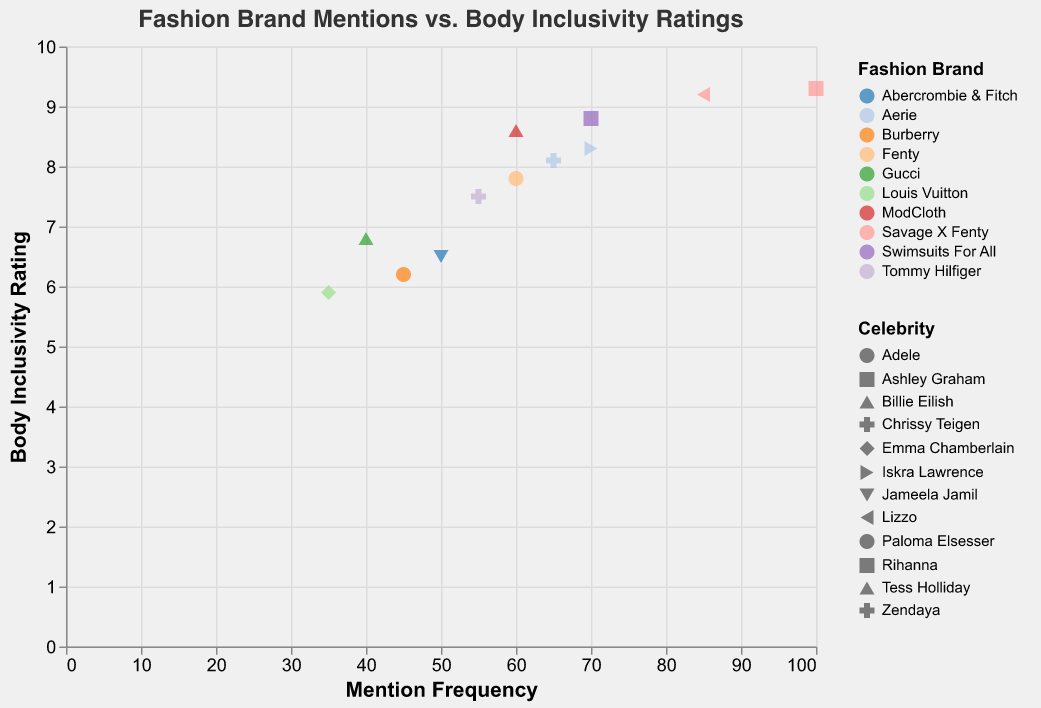What is the title of the plot? The title of the plot is located at the top and it provides a brief summary of what the plot represents.
Answer: Fashion Brand Mentions vs. Body Inclusivity Ratings Which celebrity endorses Savage X Fenty, and what is their body inclusivity rating? Locate the color corresponding to "Savage X Fenty" in the legend and find the data points. Check the celebrity and the body inclusivity rating in the tooltip.
Answer: Lizzo, 9.2, and Rihanna, 9.3 Which fashion brand has the highest mention frequency and what is it? Check the x-axis for the data point with the highest value and cross-reference with the tooltip or legend.
Answer: Savage X Fenty, 100 Compare the mention frequency and body inclusivity rating between Ashley Graham and Billie Eilish. Look for their data points using their shapes in the legend. For Ashley Graham, the mention frequency is 70 and the rating is 8.8. For Billie Eilish, the mention frequency is 40 and the rating is 6.8.
Answer: Ashley Graham: 70 mentions, 8.8 rating; Billie Eilish: 40 mentions, 6.8 rating What is the average body inclusivity rating for celebrities endorsing Aerie? Find the data points for Aerie using the color in the legend. There are two data points: Chrissy Teigen (8.1) and Iskra Lawrence (8.3). Calculate the average of these values.
Answer: (8.1 + 8.3) / 2 = 8.2 Which celebrity has the highest combination of mention frequency and body inclusivity rating? Evaluate both metrics for each data point, adding them together. The highest combination (mention frequency + body inclusivity rating) comes from Rihanna with [100 + 9.3 = 109.3].
Answer: Rihanna What is the relationship between body inclusivity ratings and mention frequencies for Aerie? Check the data points colored for Aerie and note their positions. Chrissy Teigen has 65 mentions and 8.1 rating, Iskra Lawrence has 70 mentions and 8.3 rating, suggesting a generally positive correlation.
Answer: Generally positive correlation How many fashion brands have a body inclusivity rating above 8? Count the data points where the y-axis (Body Inclusivity Rating) value is above 8.
Answer: 5 Which fashion brand endorsed by Zendaya and its body inclusivity rating? Find the shape for Zendaya in the legend and check the tooltip for the specific data point.
Answer: Tommy Hilfiger, 7.5 What notable trend can you observe with the relationship between mention frequency and body inclusivity rating? Summarize the general pattern observed in the scatter plot. Higher mention frequencies tend to correlate with higher body inclusivity ratings, especially for brands like Savage X Fenty.
Answer: Higher mention frequencies often correlate with higher inclusivity ratings 